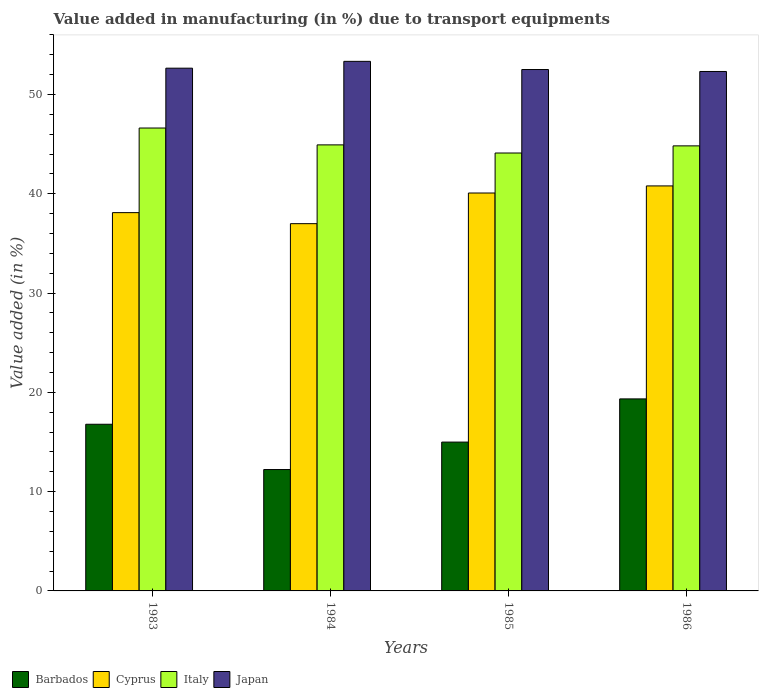Are the number of bars per tick equal to the number of legend labels?
Ensure brevity in your answer.  Yes. Are the number of bars on each tick of the X-axis equal?
Your response must be concise. Yes. What is the label of the 4th group of bars from the left?
Your response must be concise. 1986. What is the percentage of value added in manufacturing due to transport equipments in Cyprus in 1985?
Ensure brevity in your answer.  40.08. Across all years, what is the maximum percentage of value added in manufacturing due to transport equipments in Japan?
Your response must be concise. 53.34. Across all years, what is the minimum percentage of value added in manufacturing due to transport equipments in Barbados?
Your answer should be very brief. 12.23. What is the total percentage of value added in manufacturing due to transport equipments in Japan in the graph?
Give a very brief answer. 210.84. What is the difference between the percentage of value added in manufacturing due to transport equipments in Cyprus in 1984 and that in 1986?
Offer a very short reply. -3.8. What is the difference between the percentage of value added in manufacturing due to transport equipments in Japan in 1986 and the percentage of value added in manufacturing due to transport equipments in Italy in 1985?
Keep it short and to the point. 8.21. What is the average percentage of value added in manufacturing due to transport equipments in Japan per year?
Ensure brevity in your answer.  52.71. In the year 1984, what is the difference between the percentage of value added in manufacturing due to transport equipments in Barbados and percentage of value added in manufacturing due to transport equipments in Italy?
Ensure brevity in your answer.  -32.7. In how many years, is the percentage of value added in manufacturing due to transport equipments in Italy greater than 6 %?
Your answer should be compact. 4. What is the ratio of the percentage of value added in manufacturing due to transport equipments in Barbados in 1983 to that in 1984?
Your response must be concise. 1.37. What is the difference between the highest and the second highest percentage of value added in manufacturing due to transport equipments in Italy?
Your answer should be very brief. 1.7. What is the difference between the highest and the lowest percentage of value added in manufacturing due to transport equipments in Japan?
Ensure brevity in your answer.  1.02. In how many years, is the percentage of value added in manufacturing due to transport equipments in Italy greater than the average percentage of value added in manufacturing due to transport equipments in Italy taken over all years?
Your answer should be very brief. 1. Is the sum of the percentage of value added in manufacturing due to transport equipments in Barbados in 1983 and 1984 greater than the maximum percentage of value added in manufacturing due to transport equipments in Cyprus across all years?
Your answer should be compact. No. What does the 4th bar from the right in 1986 represents?
Keep it short and to the point. Barbados. Is it the case that in every year, the sum of the percentage of value added in manufacturing due to transport equipments in Cyprus and percentage of value added in manufacturing due to transport equipments in Italy is greater than the percentage of value added in manufacturing due to transport equipments in Barbados?
Give a very brief answer. Yes. What is the difference between two consecutive major ticks on the Y-axis?
Provide a short and direct response. 10. Does the graph contain any zero values?
Your answer should be very brief. No. What is the title of the graph?
Your response must be concise. Value added in manufacturing (in %) due to transport equipments. What is the label or title of the Y-axis?
Provide a short and direct response. Value added (in %). What is the Value added (in %) in Barbados in 1983?
Ensure brevity in your answer.  16.79. What is the Value added (in %) of Cyprus in 1983?
Make the answer very short. 38.1. What is the Value added (in %) in Italy in 1983?
Offer a very short reply. 46.63. What is the Value added (in %) in Japan in 1983?
Provide a short and direct response. 52.65. What is the Value added (in %) of Barbados in 1984?
Offer a very short reply. 12.23. What is the Value added (in %) in Cyprus in 1984?
Provide a short and direct response. 36.99. What is the Value added (in %) of Italy in 1984?
Provide a succinct answer. 44.93. What is the Value added (in %) of Japan in 1984?
Provide a short and direct response. 53.34. What is the Value added (in %) in Barbados in 1985?
Your answer should be very brief. 14.99. What is the Value added (in %) in Cyprus in 1985?
Provide a succinct answer. 40.08. What is the Value added (in %) of Italy in 1985?
Make the answer very short. 44.11. What is the Value added (in %) of Japan in 1985?
Keep it short and to the point. 52.52. What is the Value added (in %) of Barbados in 1986?
Make the answer very short. 19.34. What is the Value added (in %) of Cyprus in 1986?
Offer a very short reply. 40.79. What is the Value added (in %) in Italy in 1986?
Make the answer very short. 44.83. What is the Value added (in %) in Japan in 1986?
Make the answer very short. 52.32. Across all years, what is the maximum Value added (in %) of Barbados?
Your answer should be very brief. 19.34. Across all years, what is the maximum Value added (in %) in Cyprus?
Your answer should be compact. 40.79. Across all years, what is the maximum Value added (in %) of Italy?
Keep it short and to the point. 46.63. Across all years, what is the maximum Value added (in %) of Japan?
Your answer should be very brief. 53.34. Across all years, what is the minimum Value added (in %) of Barbados?
Keep it short and to the point. 12.23. Across all years, what is the minimum Value added (in %) of Cyprus?
Your answer should be very brief. 36.99. Across all years, what is the minimum Value added (in %) of Italy?
Offer a very short reply. 44.11. Across all years, what is the minimum Value added (in %) of Japan?
Offer a very short reply. 52.32. What is the total Value added (in %) of Barbados in the graph?
Make the answer very short. 63.35. What is the total Value added (in %) in Cyprus in the graph?
Ensure brevity in your answer.  155.97. What is the total Value added (in %) of Italy in the graph?
Your answer should be compact. 180.49. What is the total Value added (in %) in Japan in the graph?
Keep it short and to the point. 210.84. What is the difference between the Value added (in %) in Barbados in 1983 and that in 1984?
Provide a short and direct response. 4.56. What is the difference between the Value added (in %) in Italy in 1983 and that in 1984?
Your answer should be very brief. 1.7. What is the difference between the Value added (in %) in Japan in 1983 and that in 1984?
Offer a terse response. -0.69. What is the difference between the Value added (in %) in Barbados in 1983 and that in 1985?
Offer a very short reply. 1.8. What is the difference between the Value added (in %) of Cyprus in 1983 and that in 1985?
Your response must be concise. -1.98. What is the difference between the Value added (in %) of Italy in 1983 and that in 1985?
Keep it short and to the point. 2.52. What is the difference between the Value added (in %) of Japan in 1983 and that in 1985?
Offer a very short reply. 0.14. What is the difference between the Value added (in %) in Barbados in 1983 and that in 1986?
Your answer should be compact. -2.55. What is the difference between the Value added (in %) of Cyprus in 1983 and that in 1986?
Give a very brief answer. -2.69. What is the difference between the Value added (in %) in Italy in 1983 and that in 1986?
Keep it short and to the point. 1.8. What is the difference between the Value added (in %) in Japan in 1983 and that in 1986?
Make the answer very short. 0.33. What is the difference between the Value added (in %) in Barbados in 1984 and that in 1985?
Provide a short and direct response. -2.76. What is the difference between the Value added (in %) of Cyprus in 1984 and that in 1985?
Provide a short and direct response. -3.09. What is the difference between the Value added (in %) in Italy in 1984 and that in 1985?
Keep it short and to the point. 0.82. What is the difference between the Value added (in %) of Japan in 1984 and that in 1985?
Offer a very short reply. 0.82. What is the difference between the Value added (in %) in Barbados in 1984 and that in 1986?
Your answer should be very brief. -7.12. What is the difference between the Value added (in %) of Cyprus in 1984 and that in 1986?
Give a very brief answer. -3.8. What is the difference between the Value added (in %) in Italy in 1984 and that in 1986?
Give a very brief answer. 0.1. What is the difference between the Value added (in %) of Barbados in 1985 and that in 1986?
Give a very brief answer. -4.35. What is the difference between the Value added (in %) in Cyprus in 1985 and that in 1986?
Make the answer very short. -0.71. What is the difference between the Value added (in %) of Italy in 1985 and that in 1986?
Give a very brief answer. -0.72. What is the difference between the Value added (in %) of Japan in 1985 and that in 1986?
Ensure brevity in your answer.  0.2. What is the difference between the Value added (in %) in Barbados in 1983 and the Value added (in %) in Cyprus in 1984?
Provide a short and direct response. -20.2. What is the difference between the Value added (in %) in Barbados in 1983 and the Value added (in %) in Italy in 1984?
Offer a very short reply. -28.14. What is the difference between the Value added (in %) of Barbados in 1983 and the Value added (in %) of Japan in 1984?
Your response must be concise. -36.55. What is the difference between the Value added (in %) in Cyprus in 1983 and the Value added (in %) in Italy in 1984?
Provide a short and direct response. -6.82. What is the difference between the Value added (in %) of Cyprus in 1983 and the Value added (in %) of Japan in 1984?
Offer a very short reply. -15.24. What is the difference between the Value added (in %) of Italy in 1983 and the Value added (in %) of Japan in 1984?
Your response must be concise. -6.72. What is the difference between the Value added (in %) in Barbados in 1983 and the Value added (in %) in Cyprus in 1985?
Your answer should be compact. -23.29. What is the difference between the Value added (in %) of Barbados in 1983 and the Value added (in %) of Italy in 1985?
Your response must be concise. -27.32. What is the difference between the Value added (in %) of Barbados in 1983 and the Value added (in %) of Japan in 1985?
Give a very brief answer. -35.73. What is the difference between the Value added (in %) in Cyprus in 1983 and the Value added (in %) in Italy in 1985?
Offer a very short reply. -6.01. What is the difference between the Value added (in %) of Cyprus in 1983 and the Value added (in %) of Japan in 1985?
Offer a terse response. -14.42. What is the difference between the Value added (in %) in Italy in 1983 and the Value added (in %) in Japan in 1985?
Give a very brief answer. -5.89. What is the difference between the Value added (in %) of Barbados in 1983 and the Value added (in %) of Cyprus in 1986?
Your response must be concise. -24.01. What is the difference between the Value added (in %) in Barbados in 1983 and the Value added (in %) in Italy in 1986?
Ensure brevity in your answer.  -28.04. What is the difference between the Value added (in %) in Barbados in 1983 and the Value added (in %) in Japan in 1986?
Offer a terse response. -35.53. What is the difference between the Value added (in %) of Cyprus in 1983 and the Value added (in %) of Italy in 1986?
Provide a succinct answer. -6.73. What is the difference between the Value added (in %) in Cyprus in 1983 and the Value added (in %) in Japan in 1986?
Offer a very short reply. -14.22. What is the difference between the Value added (in %) in Italy in 1983 and the Value added (in %) in Japan in 1986?
Your answer should be compact. -5.7. What is the difference between the Value added (in %) of Barbados in 1984 and the Value added (in %) of Cyprus in 1985?
Provide a short and direct response. -27.85. What is the difference between the Value added (in %) of Barbados in 1984 and the Value added (in %) of Italy in 1985?
Offer a very short reply. -31.88. What is the difference between the Value added (in %) in Barbados in 1984 and the Value added (in %) in Japan in 1985?
Provide a succinct answer. -40.29. What is the difference between the Value added (in %) in Cyprus in 1984 and the Value added (in %) in Italy in 1985?
Make the answer very short. -7.12. What is the difference between the Value added (in %) of Cyprus in 1984 and the Value added (in %) of Japan in 1985?
Your answer should be very brief. -15.53. What is the difference between the Value added (in %) of Italy in 1984 and the Value added (in %) of Japan in 1985?
Your response must be concise. -7.59. What is the difference between the Value added (in %) of Barbados in 1984 and the Value added (in %) of Cyprus in 1986?
Provide a succinct answer. -28.57. What is the difference between the Value added (in %) of Barbados in 1984 and the Value added (in %) of Italy in 1986?
Make the answer very short. -32.6. What is the difference between the Value added (in %) in Barbados in 1984 and the Value added (in %) in Japan in 1986?
Provide a succinct answer. -40.1. What is the difference between the Value added (in %) of Cyprus in 1984 and the Value added (in %) of Italy in 1986?
Give a very brief answer. -7.84. What is the difference between the Value added (in %) in Cyprus in 1984 and the Value added (in %) in Japan in 1986?
Keep it short and to the point. -15.33. What is the difference between the Value added (in %) in Italy in 1984 and the Value added (in %) in Japan in 1986?
Your answer should be very brief. -7.39. What is the difference between the Value added (in %) of Barbados in 1985 and the Value added (in %) of Cyprus in 1986?
Your answer should be compact. -25.8. What is the difference between the Value added (in %) of Barbados in 1985 and the Value added (in %) of Italy in 1986?
Keep it short and to the point. -29.84. What is the difference between the Value added (in %) of Barbados in 1985 and the Value added (in %) of Japan in 1986?
Offer a terse response. -37.33. What is the difference between the Value added (in %) in Cyprus in 1985 and the Value added (in %) in Italy in 1986?
Make the answer very short. -4.75. What is the difference between the Value added (in %) in Cyprus in 1985 and the Value added (in %) in Japan in 1986?
Provide a succinct answer. -12.24. What is the difference between the Value added (in %) in Italy in 1985 and the Value added (in %) in Japan in 1986?
Keep it short and to the point. -8.21. What is the average Value added (in %) in Barbados per year?
Offer a terse response. 15.84. What is the average Value added (in %) in Cyprus per year?
Provide a short and direct response. 38.99. What is the average Value added (in %) in Italy per year?
Your answer should be compact. 45.12. What is the average Value added (in %) of Japan per year?
Give a very brief answer. 52.71. In the year 1983, what is the difference between the Value added (in %) of Barbados and Value added (in %) of Cyprus?
Keep it short and to the point. -21.32. In the year 1983, what is the difference between the Value added (in %) of Barbados and Value added (in %) of Italy?
Ensure brevity in your answer.  -29.84. In the year 1983, what is the difference between the Value added (in %) of Barbados and Value added (in %) of Japan?
Your answer should be very brief. -35.87. In the year 1983, what is the difference between the Value added (in %) in Cyprus and Value added (in %) in Italy?
Your answer should be compact. -8.52. In the year 1983, what is the difference between the Value added (in %) of Cyprus and Value added (in %) of Japan?
Give a very brief answer. -14.55. In the year 1983, what is the difference between the Value added (in %) of Italy and Value added (in %) of Japan?
Ensure brevity in your answer.  -6.03. In the year 1984, what is the difference between the Value added (in %) of Barbados and Value added (in %) of Cyprus?
Make the answer very short. -24.77. In the year 1984, what is the difference between the Value added (in %) in Barbados and Value added (in %) in Italy?
Your answer should be very brief. -32.7. In the year 1984, what is the difference between the Value added (in %) in Barbados and Value added (in %) in Japan?
Make the answer very short. -41.11. In the year 1984, what is the difference between the Value added (in %) in Cyprus and Value added (in %) in Italy?
Provide a succinct answer. -7.94. In the year 1984, what is the difference between the Value added (in %) in Cyprus and Value added (in %) in Japan?
Make the answer very short. -16.35. In the year 1984, what is the difference between the Value added (in %) of Italy and Value added (in %) of Japan?
Offer a very short reply. -8.41. In the year 1985, what is the difference between the Value added (in %) in Barbados and Value added (in %) in Cyprus?
Provide a short and direct response. -25.09. In the year 1985, what is the difference between the Value added (in %) in Barbados and Value added (in %) in Italy?
Ensure brevity in your answer.  -29.12. In the year 1985, what is the difference between the Value added (in %) in Barbados and Value added (in %) in Japan?
Your response must be concise. -37.53. In the year 1985, what is the difference between the Value added (in %) in Cyprus and Value added (in %) in Italy?
Give a very brief answer. -4.03. In the year 1985, what is the difference between the Value added (in %) in Cyprus and Value added (in %) in Japan?
Keep it short and to the point. -12.44. In the year 1985, what is the difference between the Value added (in %) in Italy and Value added (in %) in Japan?
Give a very brief answer. -8.41. In the year 1986, what is the difference between the Value added (in %) of Barbados and Value added (in %) of Cyprus?
Provide a succinct answer. -21.45. In the year 1986, what is the difference between the Value added (in %) of Barbados and Value added (in %) of Italy?
Keep it short and to the point. -25.49. In the year 1986, what is the difference between the Value added (in %) in Barbados and Value added (in %) in Japan?
Ensure brevity in your answer.  -32.98. In the year 1986, what is the difference between the Value added (in %) of Cyprus and Value added (in %) of Italy?
Make the answer very short. -4.03. In the year 1986, what is the difference between the Value added (in %) in Cyprus and Value added (in %) in Japan?
Your response must be concise. -11.53. In the year 1986, what is the difference between the Value added (in %) of Italy and Value added (in %) of Japan?
Make the answer very short. -7.49. What is the ratio of the Value added (in %) in Barbados in 1983 to that in 1984?
Provide a short and direct response. 1.37. What is the ratio of the Value added (in %) of Cyprus in 1983 to that in 1984?
Your answer should be compact. 1.03. What is the ratio of the Value added (in %) of Italy in 1983 to that in 1984?
Provide a succinct answer. 1.04. What is the ratio of the Value added (in %) of Japan in 1983 to that in 1984?
Offer a terse response. 0.99. What is the ratio of the Value added (in %) in Barbados in 1983 to that in 1985?
Make the answer very short. 1.12. What is the ratio of the Value added (in %) in Cyprus in 1983 to that in 1985?
Offer a very short reply. 0.95. What is the ratio of the Value added (in %) in Italy in 1983 to that in 1985?
Your answer should be compact. 1.06. What is the ratio of the Value added (in %) of Japan in 1983 to that in 1985?
Your answer should be compact. 1. What is the ratio of the Value added (in %) in Barbados in 1983 to that in 1986?
Provide a short and direct response. 0.87. What is the ratio of the Value added (in %) in Cyprus in 1983 to that in 1986?
Provide a short and direct response. 0.93. What is the ratio of the Value added (in %) of Italy in 1983 to that in 1986?
Keep it short and to the point. 1.04. What is the ratio of the Value added (in %) in Japan in 1983 to that in 1986?
Provide a succinct answer. 1.01. What is the ratio of the Value added (in %) in Barbados in 1984 to that in 1985?
Your answer should be compact. 0.82. What is the ratio of the Value added (in %) in Cyprus in 1984 to that in 1985?
Your answer should be compact. 0.92. What is the ratio of the Value added (in %) of Italy in 1984 to that in 1985?
Ensure brevity in your answer.  1.02. What is the ratio of the Value added (in %) of Japan in 1984 to that in 1985?
Keep it short and to the point. 1.02. What is the ratio of the Value added (in %) of Barbados in 1984 to that in 1986?
Your response must be concise. 0.63. What is the ratio of the Value added (in %) in Cyprus in 1984 to that in 1986?
Keep it short and to the point. 0.91. What is the ratio of the Value added (in %) in Japan in 1984 to that in 1986?
Provide a succinct answer. 1.02. What is the ratio of the Value added (in %) of Barbados in 1985 to that in 1986?
Provide a succinct answer. 0.78. What is the ratio of the Value added (in %) of Cyprus in 1985 to that in 1986?
Make the answer very short. 0.98. What is the ratio of the Value added (in %) of Italy in 1985 to that in 1986?
Your response must be concise. 0.98. What is the ratio of the Value added (in %) of Japan in 1985 to that in 1986?
Offer a very short reply. 1. What is the difference between the highest and the second highest Value added (in %) of Barbados?
Ensure brevity in your answer.  2.55. What is the difference between the highest and the second highest Value added (in %) of Cyprus?
Give a very brief answer. 0.71. What is the difference between the highest and the second highest Value added (in %) of Italy?
Offer a terse response. 1.7. What is the difference between the highest and the second highest Value added (in %) of Japan?
Offer a very short reply. 0.69. What is the difference between the highest and the lowest Value added (in %) of Barbados?
Offer a very short reply. 7.12. What is the difference between the highest and the lowest Value added (in %) in Cyprus?
Provide a succinct answer. 3.8. What is the difference between the highest and the lowest Value added (in %) in Italy?
Provide a short and direct response. 2.52. What is the difference between the highest and the lowest Value added (in %) in Japan?
Your answer should be compact. 1.02. 